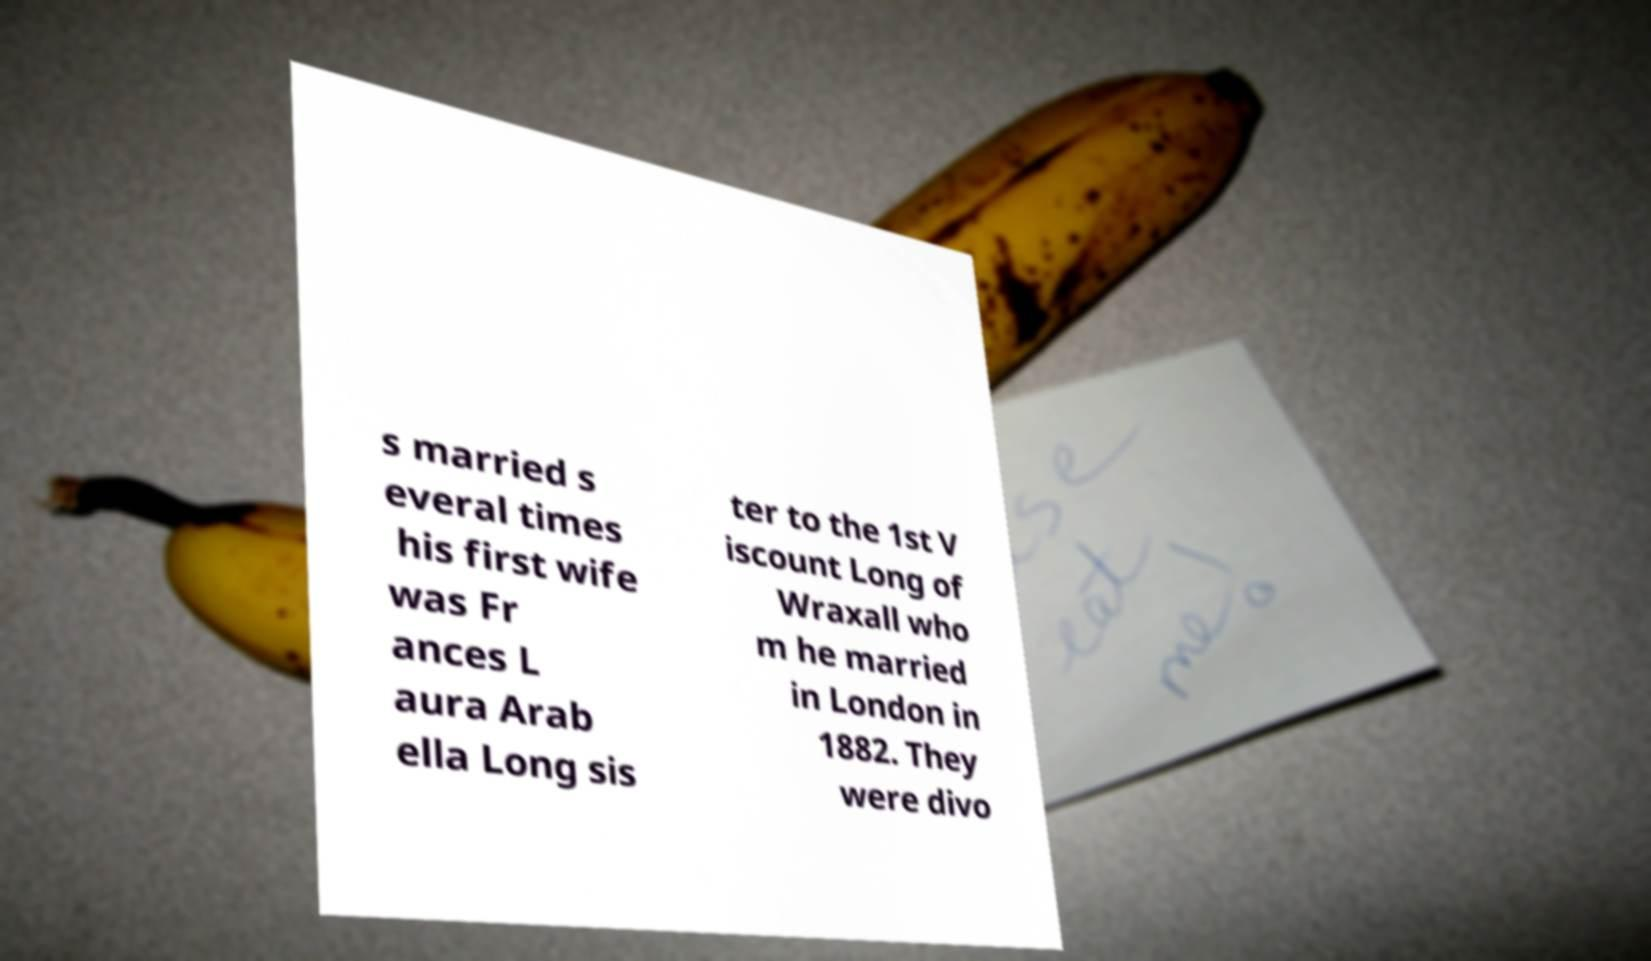There's text embedded in this image that I need extracted. Can you transcribe it verbatim? s married s everal times his first wife was Fr ances L aura Arab ella Long sis ter to the 1st V iscount Long of Wraxall who m he married in London in 1882. They were divo 